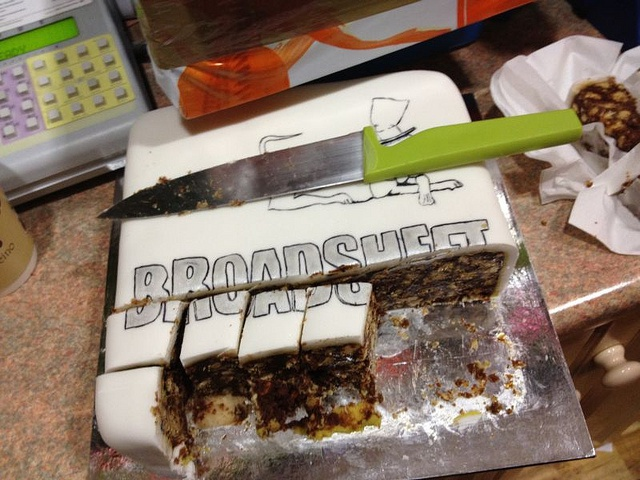Describe the objects in this image and their specific colors. I can see cake in lightgray, darkgray, black, and gray tones, cake in lightgray, black, maroon, and darkgray tones, cake in lightgray, darkgray, maroon, and gray tones, knife in lightgray, olive, gray, and black tones, and cake in lightgray, maroon, black, and gray tones in this image. 